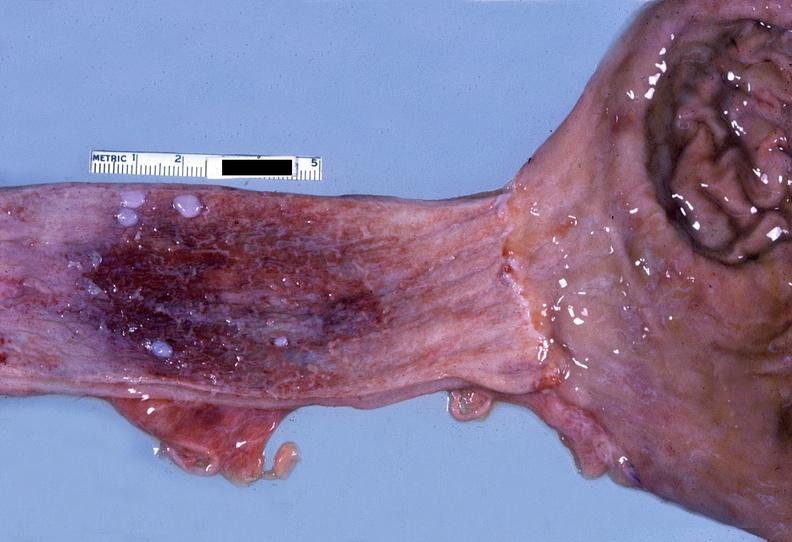where does this belong to?
Answer the question using a single word or phrase. Gastrointestinal system 